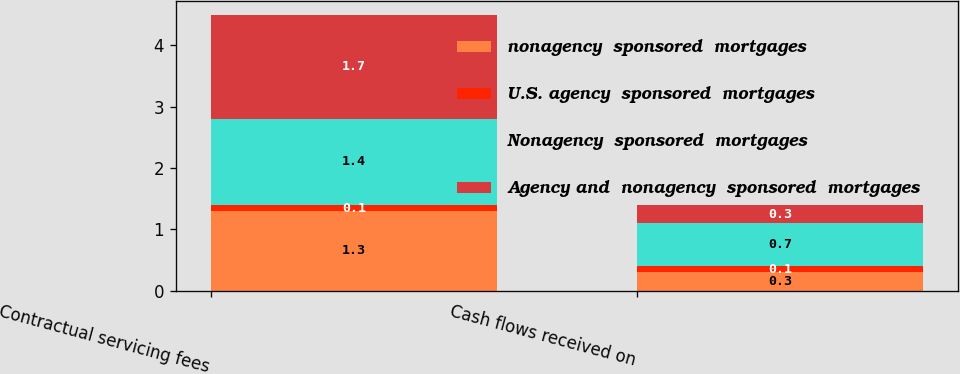Convert chart. <chart><loc_0><loc_0><loc_500><loc_500><stacked_bar_chart><ecel><fcel>Contractual servicing fees<fcel>Cash flows received on<nl><fcel>nonagency  sponsored  mortgages<fcel>1.3<fcel>0.3<nl><fcel>U.S. agency  sponsored  mortgages<fcel>0.1<fcel>0.1<nl><fcel>Nonagency  sponsored  mortgages<fcel>1.4<fcel>0.7<nl><fcel>Agency and  nonagency  sponsored  mortgages<fcel>1.7<fcel>0.3<nl></chart> 